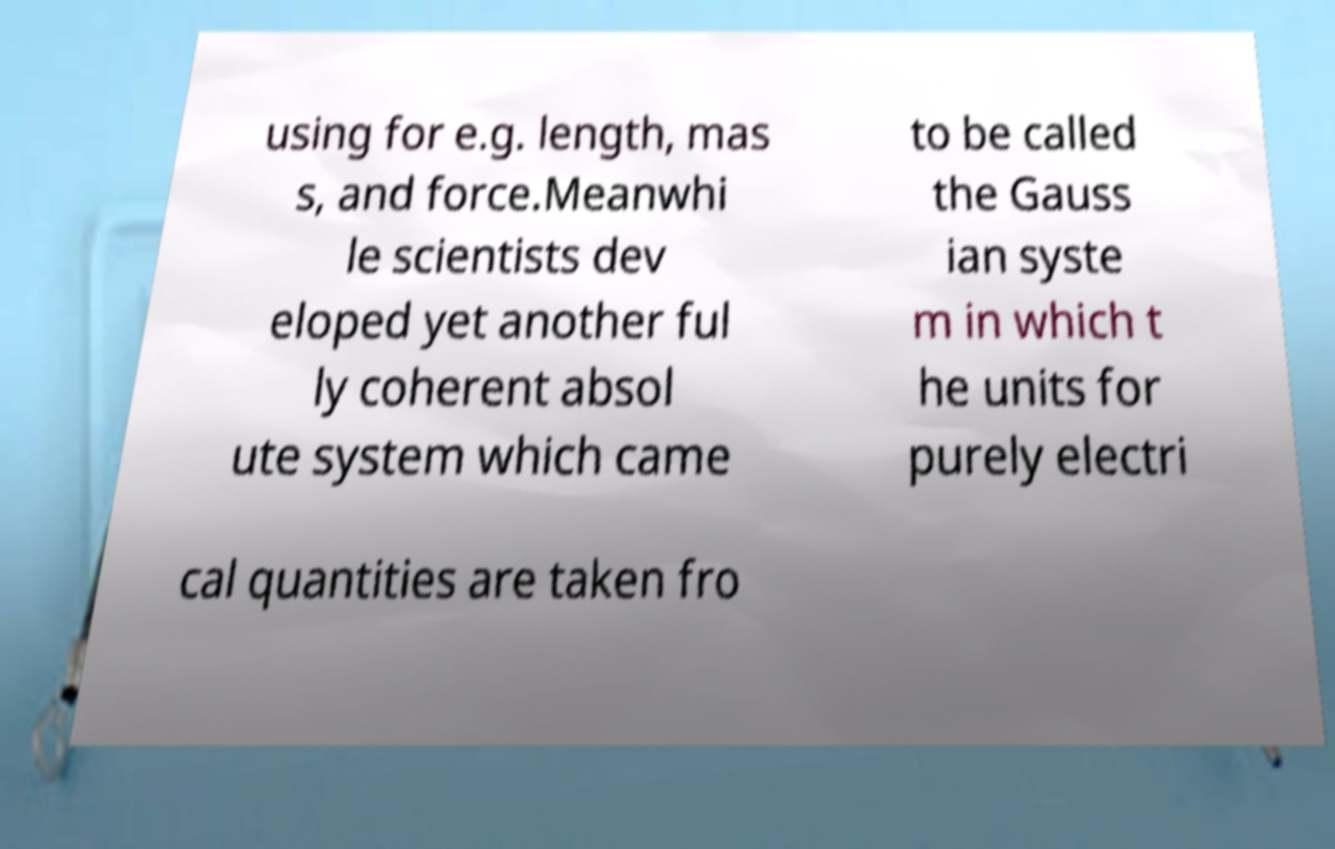Could you assist in decoding the text presented in this image and type it out clearly? using for e.g. length, mas s, and force.Meanwhi le scientists dev eloped yet another ful ly coherent absol ute system which came to be called the Gauss ian syste m in which t he units for purely electri cal quantities are taken fro 